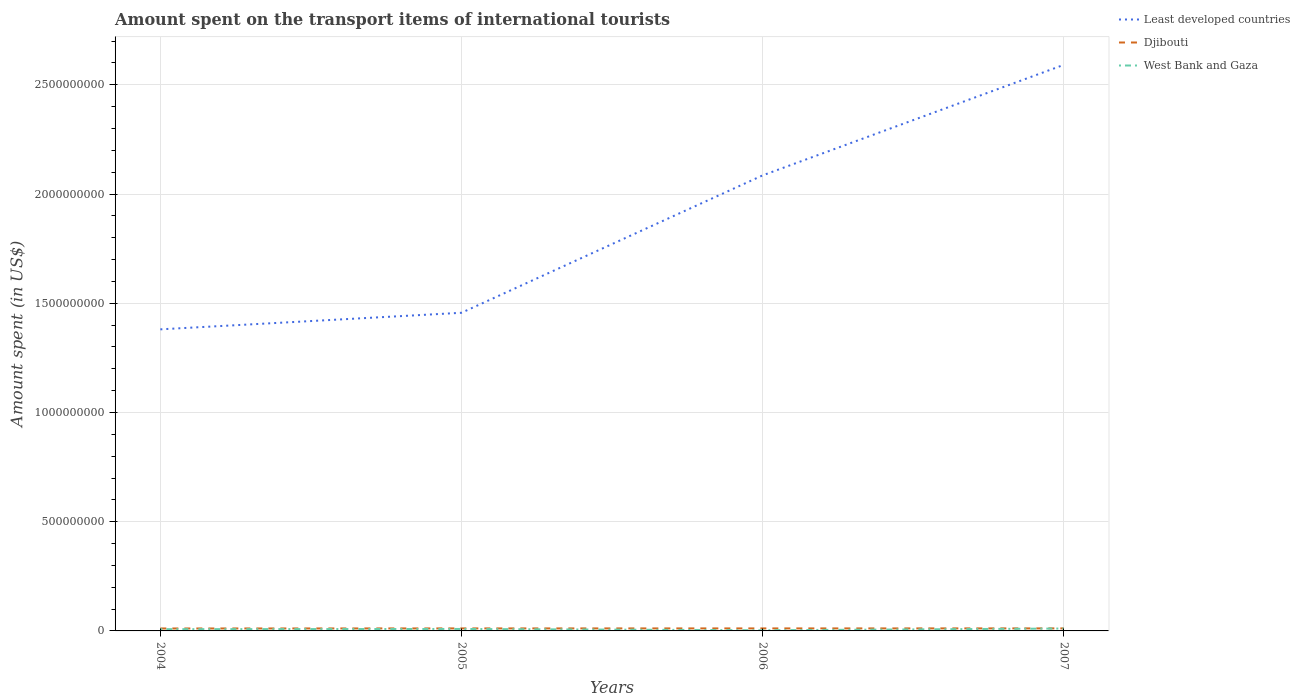Is the number of lines equal to the number of legend labels?
Give a very brief answer. Yes. Across all years, what is the maximum amount spent on the transport items of international tourists in Djibouti?
Keep it short and to the point. 1.12e+07. What is the total amount spent on the transport items of international tourists in Djibouti in the graph?
Offer a terse response. -1.00e+05. What is the difference between the highest and the second highest amount spent on the transport items of international tourists in Djibouti?
Ensure brevity in your answer.  4.00e+05. How many lines are there?
Make the answer very short. 3. How many years are there in the graph?
Make the answer very short. 4. Does the graph contain any zero values?
Offer a terse response. No. Does the graph contain grids?
Your answer should be compact. Yes. Where does the legend appear in the graph?
Provide a succinct answer. Top right. How many legend labels are there?
Ensure brevity in your answer.  3. How are the legend labels stacked?
Offer a very short reply. Vertical. What is the title of the graph?
Keep it short and to the point. Amount spent on the transport items of international tourists. Does "Bahamas" appear as one of the legend labels in the graph?
Provide a succinct answer. No. What is the label or title of the Y-axis?
Your answer should be compact. Amount spent (in US$). What is the Amount spent (in US$) of Least developed countries in 2004?
Make the answer very short. 1.38e+09. What is the Amount spent (in US$) in Djibouti in 2004?
Give a very brief answer. 1.12e+07. What is the Amount spent (in US$) of Least developed countries in 2005?
Make the answer very short. 1.46e+09. What is the Amount spent (in US$) of Djibouti in 2005?
Your answer should be compact. 1.15e+07. What is the Amount spent (in US$) of West Bank and Gaza in 2005?
Provide a short and direct response. 9.00e+06. What is the Amount spent (in US$) in Least developed countries in 2006?
Ensure brevity in your answer.  2.09e+09. What is the Amount spent (in US$) in Djibouti in 2006?
Offer a very short reply. 1.15e+07. What is the Amount spent (in US$) of Least developed countries in 2007?
Your response must be concise. 2.59e+09. What is the Amount spent (in US$) in Djibouti in 2007?
Keep it short and to the point. 1.16e+07. What is the Amount spent (in US$) in West Bank and Gaza in 2007?
Provide a succinct answer. 1.10e+07. Across all years, what is the maximum Amount spent (in US$) of Least developed countries?
Keep it short and to the point. 2.59e+09. Across all years, what is the maximum Amount spent (in US$) in Djibouti?
Your answer should be very brief. 1.16e+07. Across all years, what is the maximum Amount spent (in US$) in West Bank and Gaza?
Provide a succinct answer. 1.10e+07. Across all years, what is the minimum Amount spent (in US$) in Least developed countries?
Your answer should be compact. 1.38e+09. Across all years, what is the minimum Amount spent (in US$) in Djibouti?
Your response must be concise. 1.12e+07. Across all years, what is the minimum Amount spent (in US$) of West Bank and Gaza?
Provide a short and direct response. 3.00e+06. What is the total Amount spent (in US$) of Least developed countries in the graph?
Ensure brevity in your answer.  7.51e+09. What is the total Amount spent (in US$) of Djibouti in the graph?
Your answer should be very brief. 4.58e+07. What is the total Amount spent (in US$) in West Bank and Gaza in the graph?
Make the answer very short. 3.10e+07. What is the difference between the Amount spent (in US$) of Least developed countries in 2004 and that in 2005?
Provide a succinct answer. -7.59e+07. What is the difference between the Amount spent (in US$) in Djibouti in 2004 and that in 2005?
Make the answer very short. -3.00e+05. What is the difference between the Amount spent (in US$) of West Bank and Gaza in 2004 and that in 2005?
Keep it short and to the point. -1.00e+06. What is the difference between the Amount spent (in US$) of Least developed countries in 2004 and that in 2006?
Your answer should be very brief. -7.05e+08. What is the difference between the Amount spent (in US$) in Djibouti in 2004 and that in 2006?
Provide a succinct answer. -3.00e+05. What is the difference between the Amount spent (in US$) in West Bank and Gaza in 2004 and that in 2006?
Ensure brevity in your answer.  5.00e+06. What is the difference between the Amount spent (in US$) of Least developed countries in 2004 and that in 2007?
Keep it short and to the point. -1.21e+09. What is the difference between the Amount spent (in US$) in Djibouti in 2004 and that in 2007?
Ensure brevity in your answer.  -4.00e+05. What is the difference between the Amount spent (in US$) in Least developed countries in 2005 and that in 2006?
Offer a terse response. -6.29e+08. What is the difference between the Amount spent (in US$) of West Bank and Gaza in 2005 and that in 2006?
Your response must be concise. 6.00e+06. What is the difference between the Amount spent (in US$) in Least developed countries in 2005 and that in 2007?
Ensure brevity in your answer.  -1.13e+09. What is the difference between the Amount spent (in US$) in Djibouti in 2005 and that in 2007?
Give a very brief answer. -1.00e+05. What is the difference between the Amount spent (in US$) in Least developed countries in 2006 and that in 2007?
Provide a succinct answer. -5.06e+08. What is the difference between the Amount spent (in US$) in West Bank and Gaza in 2006 and that in 2007?
Ensure brevity in your answer.  -8.00e+06. What is the difference between the Amount spent (in US$) of Least developed countries in 2004 and the Amount spent (in US$) of Djibouti in 2005?
Give a very brief answer. 1.37e+09. What is the difference between the Amount spent (in US$) of Least developed countries in 2004 and the Amount spent (in US$) of West Bank and Gaza in 2005?
Your answer should be compact. 1.37e+09. What is the difference between the Amount spent (in US$) in Djibouti in 2004 and the Amount spent (in US$) in West Bank and Gaza in 2005?
Ensure brevity in your answer.  2.20e+06. What is the difference between the Amount spent (in US$) of Least developed countries in 2004 and the Amount spent (in US$) of Djibouti in 2006?
Offer a very short reply. 1.37e+09. What is the difference between the Amount spent (in US$) of Least developed countries in 2004 and the Amount spent (in US$) of West Bank and Gaza in 2006?
Ensure brevity in your answer.  1.38e+09. What is the difference between the Amount spent (in US$) of Djibouti in 2004 and the Amount spent (in US$) of West Bank and Gaza in 2006?
Your response must be concise. 8.20e+06. What is the difference between the Amount spent (in US$) in Least developed countries in 2004 and the Amount spent (in US$) in Djibouti in 2007?
Provide a succinct answer. 1.37e+09. What is the difference between the Amount spent (in US$) of Least developed countries in 2004 and the Amount spent (in US$) of West Bank and Gaza in 2007?
Make the answer very short. 1.37e+09. What is the difference between the Amount spent (in US$) of Least developed countries in 2005 and the Amount spent (in US$) of Djibouti in 2006?
Make the answer very short. 1.44e+09. What is the difference between the Amount spent (in US$) of Least developed countries in 2005 and the Amount spent (in US$) of West Bank and Gaza in 2006?
Make the answer very short. 1.45e+09. What is the difference between the Amount spent (in US$) of Djibouti in 2005 and the Amount spent (in US$) of West Bank and Gaza in 2006?
Make the answer very short. 8.50e+06. What is the difference between the Amount spent (in US$) in Least developed countries in 2005 and the Amount spent (in US$) in Djibouti in 2007?
Provide a succinct answer. 1.44e+09. What is the difference between the Amount spent (in US$) in Least developed countries in 2005 and the Amount spent (in US$) in West Bank and Gaza in 2007?
Provide a short and direct response. 1.45e+09. What is the difference between the Amount spent (in US$) of Djibouti in 2005 and the Amount spent (in US$) of West Bank and Gaza in 2007?
Your response must be concise. 5.00e+05. What is the difference between the Amount spent (in US$) of Least developed countries in 2006 and the Amount spent (in US$) of Djibouti in 2007?
Give a very brief answer. 2.07e+09. What is the difference between the Amount spent (in US$) of Least developed countries in 2006 and the Amount spent (in US$) of West Bank and Gaza in 2007?
Your response must be concise. 2.07e+09. What is the average Amount spent (in US$) in Least developed countries per year?
Offer a terse response. 1.88e+09. What is the average Amount spent (in US$) of Djibouti per year?
Offer a terse response. 1.14e+07. What is the average Amount spent (in US$) in West Bank and Gaza per year?
Provide a short and direct response. 7.75e+06. In the year 2004, what is the difference between the Amount spent (in US$) in Least developed countries and Amount spent (in US$) in Djibouti?
Keep it short and to the point. 1.37e+09. In the year 2004, what is the difference between the Amount spent (in US$) in Least developed countries and Amount spent (in US$) in West Bank and Gaza?
Provide a succinct answer. 1.37e+09. In the year 2004, what is the difference between the Amount spent (in US$) in Djibouti and Amount spent (in US$) in West Bank and Gaza?
Provide a succinct answer. 3.20e+06. In the year 2005, what is the difference between the Amount spent (in US$) in Least developed countries and Amount spent (in US$) in Djibouti?
Keep it short and to the point. 1.44e+09. In the year 2005, what is the difference between the Amount spent (in US$) in Least developed countries and Amount spent (in US$) in West Bank and Gaza?
Your answer should be very brief. 1.45e+09. In the year 2005, what is the difference between the Amount spent (in US$) of Djibouti and Amount spent (in US$) of West Bank and Gaza?
Provide a short and direct response. 2.50e+06. In the year 2006, what is the difference between the Amount spent (in US$) in Least developed countries and Amount spent (in US$) in Djibouti?
Offer a very short reply. 2.07e+09. In the year 2006, what is the difference between the Amount spent (in US$) of Least developed countries and Amount spent (in US$) of West Bank and Gaza?
Your answer should be very brief. 2.08e+09. In the year 2006, what is the difference between the Amount spent (in US$) in Djibouti and Amount spent (in US$) in West Bank and Gaza?
Keep it short and to the point. 8.50e+06. In the year 2007, what is the difference between the Amount spent (in US$) of Least developed countries and Amount spent (in US$) of Djibouti?
Keep it short and to the point. 2.58e+09. In the year 2007, what is the difference between the Amount spent (in US$) of Least developed countries and Amount spent (in US$) of West Bank and Gaza?
Your response must be concise. 2.58e+09. What is the ratio of the Amount spent (in US$) of Least developed countries in 2004 to that in 2005?
Provide a short and direct response. 0.95. What is the ratio of the Amount spent (in US$) of Djibouti in 2004 to that in 2005?
Offer a terse response. 0.97. What is the ratio of the Amount spent (in US$) in Least developed countries in 2004 to that in 2006?
Your response must be concise. 0.66. What is the ratio of the Amount spent (in US$) of Djibouti in 2004 to that in 2006?
Ensure brevity in your answer.  0.97. What is the ratio of the Amount spent (in US$) in West Bank and Gaza in 2004 to that in 2006?
Offer a very short reply. 2.67. What is the ratio of the Amount spent (in US$) in Least developed countries in 2004 to that in 2007?
Your answer should be compact. 0.53. What is the ratio of the Amount spent (in US$) in Djibouti in 2004 to that in 2007?
Offer a terse response. 0.97. What is the ratio of the Amount spent (in US$) of West Bank and Gaza in 2004 to that in 2007?
Give a very brief answer. 0.73. What is the ratio of the Amount spent (in US$) of Least developed countries in 2005 to that in 2006?
Your answer should be very brief. 0.7. What is the ratio of the Amount spent (in US$) of West Bank and Gaza in 2005 to that in 2006?
Provide a short and direct response. 3. What is the ratio of the Amount spent (in US$) in Least developed countries in 2005 to that in 2007?
Ensure brevity in your answer.  0.56. What is the ratio of the Amount spent (in US$) in Djibouti in 2005 to that in 2007?
Provide a succinct answer. 0.99. What is the ratio of the Amount spent (in US$) in West Bank and Gaza in 2005 to that in 2007?
Provide a short and direct response. 0.82. What is the ratio of the Amount spent (in US$) in Least developed countries in 2006 to that in 2007?
Offer a terse response. 0.8. What is the ratio of the Amount spent (in US$) in Djibouti in 2006 to that in 2007?
Provide a succinct answer. 0.99. What is the ratio of the Amount spent (in US$) in West Bank and Gaza in 2006 to that in 2007?
Provide a succinct answer. 0.27. What is the difference between the highest and the second highest Amount spent (in US$) of Least developed countries?
Make the answer very short. 5.06e+08. What is the difference between the highest and the second highest Amount spent (in US$) of West Bank and Gaza?
Your answer should be very brief. 2.00e+06. What is the difference between the highest and the lowest Amount spent (in US$) in Least developed countries?
Keep it short and to the point. 1.21e+09. What is the difference between the highest and the lowest Amount spent (in US$) of Djibouti?
Ensure brevity in your answer.  4.00e+05. What is the difference between the highest and the lowest Amount spent (in US$) of West Bank and Gaza?
Your answer should be compact. 8.00e+06. 